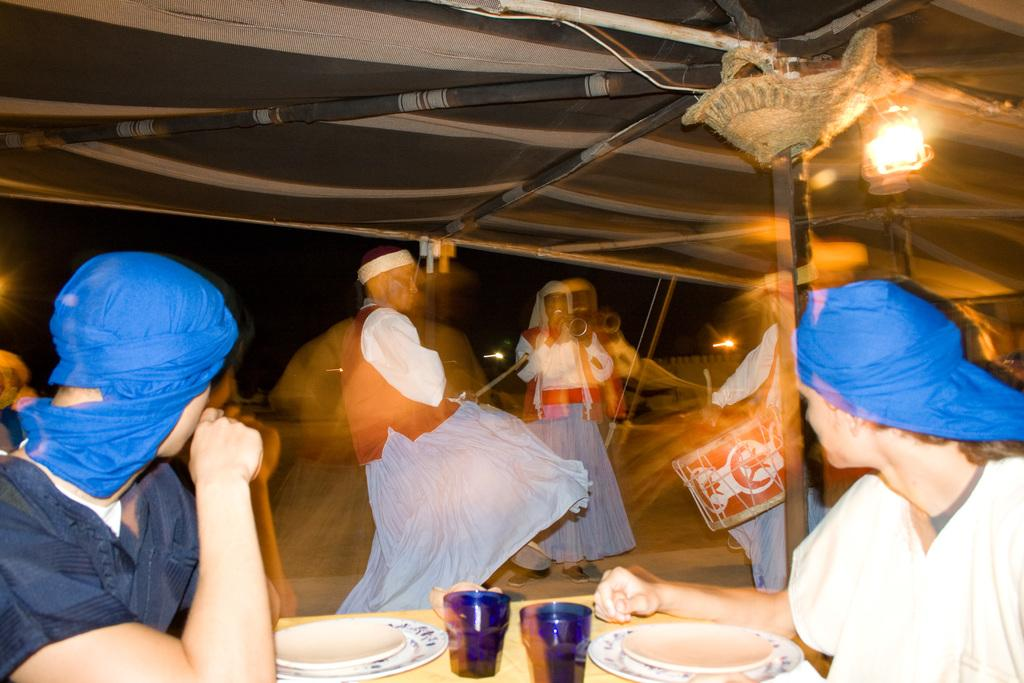What are the two people in the image doing? The two people in the image are playing musical instruments. What is the person holding in their hand? One person is holding a stick. What type of shelter is visible in the image? There is a tent in the image. What type of lighting is present under the tent? A lantern lamp is present under the tent. Who is under the tent? There are people under the tent. What items are on the table? There are glasses and plates on the table. What type of leather is being used to make the ocean visible in the image? There is no leather or ocean present in the image. How many oranges are visible on the table in the image? There are no oranges visible on the table in the image. 